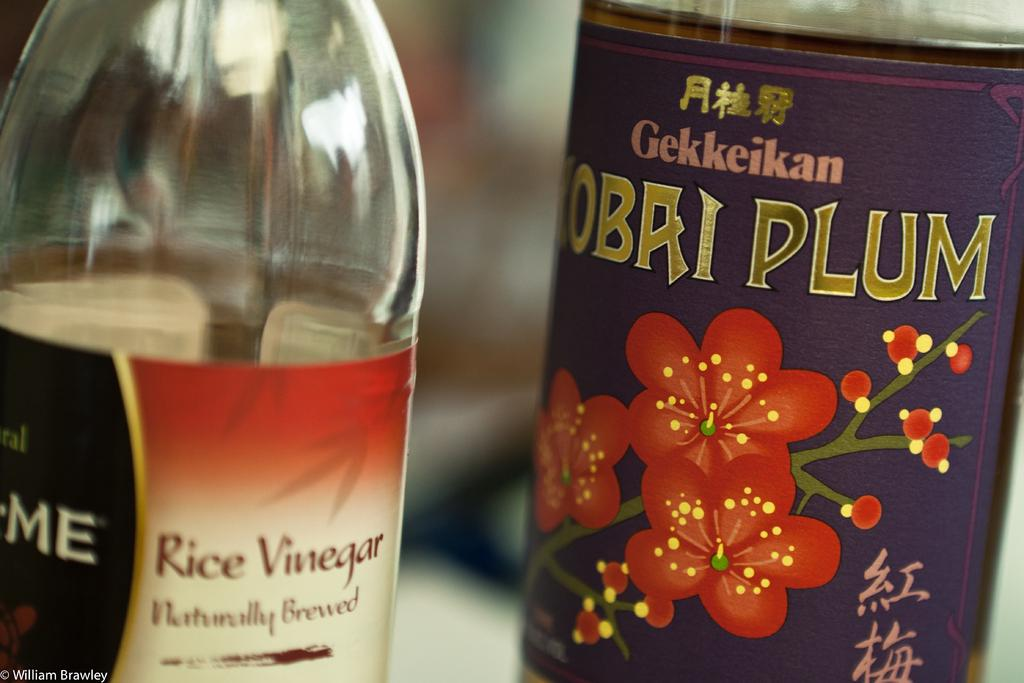<image>
Provide a brief description of the given image. A plum flavored drink sits next to a bottle labeled "Rice Vinegar." 